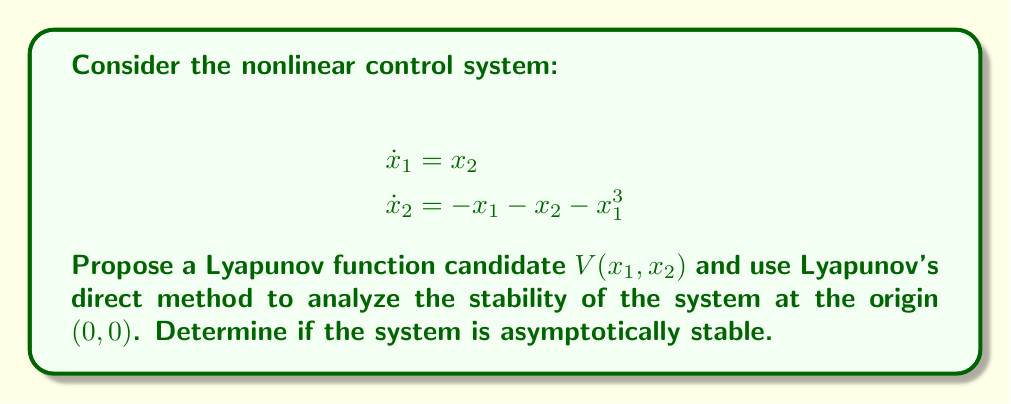Can you answer this question? 1. Let's propose a Lyapunov function candidate:
   $$V(x_1, x_2) = \frac{1}{2}x_1^2 + \frac{1}{2}x_2^2$$

2. Check if $V(x_1, x_2)$ is positive definite:
   $V(x_1, x_2) > 0$ for all $(x_1, x_2) \neq (0,0)$, and $V(0,0) = 0$. This condition is satisfied.

3. Calculate the time derivative of $V$:
   $$\dot{V} = \frac{\partial V}{\partial x_1}\dot{x}_1 + \frac{\partial V}{\partial x_2}\dot{x}_2$$
   $$\dot{V} = x_1\dot{x}_1 + x_2\dot{x}_2$$
   $$\dot{V} = x_1x_2 + x_2(-x_1 - x_2 - x_1^3)$$
   $$\dot{V} = -x_2^2 - x_1x_2x_1^2$$

4. Analyze $\dot{V}$:
   $\dot{V} = -x_2^2 - x_1x_2x_1^2 = -x_2^2 - x_1^3x_2$
   This is negative definite if $x_2 \neq 0$ or if $x_1 \neq 0$ and $x_2 \neq 0$.
   However, when $x_2 = 0$ and $x_1 \neq 0$, $\dot{V} = 0$.

5. Apply LaSalle's Invariance Principle:
   The set where $\dot{V} = 0$ is $\{(x_1, 0) | x_1 \in \mathbb{R}\}$.
   In this set, the system dynamics become:
   $$\dot{x}_1 = 0$$
   $$\dot{x}_2 = -x_1 - x_1^3$$
   The only invariant subset of this set is the origin $(0,0)$.

6. Conclusion:
   By LaSalle's Invariance Principle, all trajectories converge to the origin.
Answer: The system is asymptotically stable at the origin $(0,0)$. 